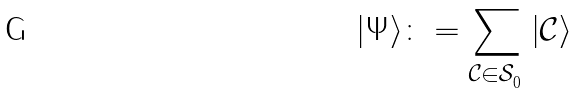Convert formula to latex. <formula><loc_0><loc_0><loc_500><loc_500>| \Psi \rangle \colon = \sum _ { \mathcal { C } \in \mathcal { S } ^ { \ } _ { 0 } } | \mathcal { C } \rangle</formula> 